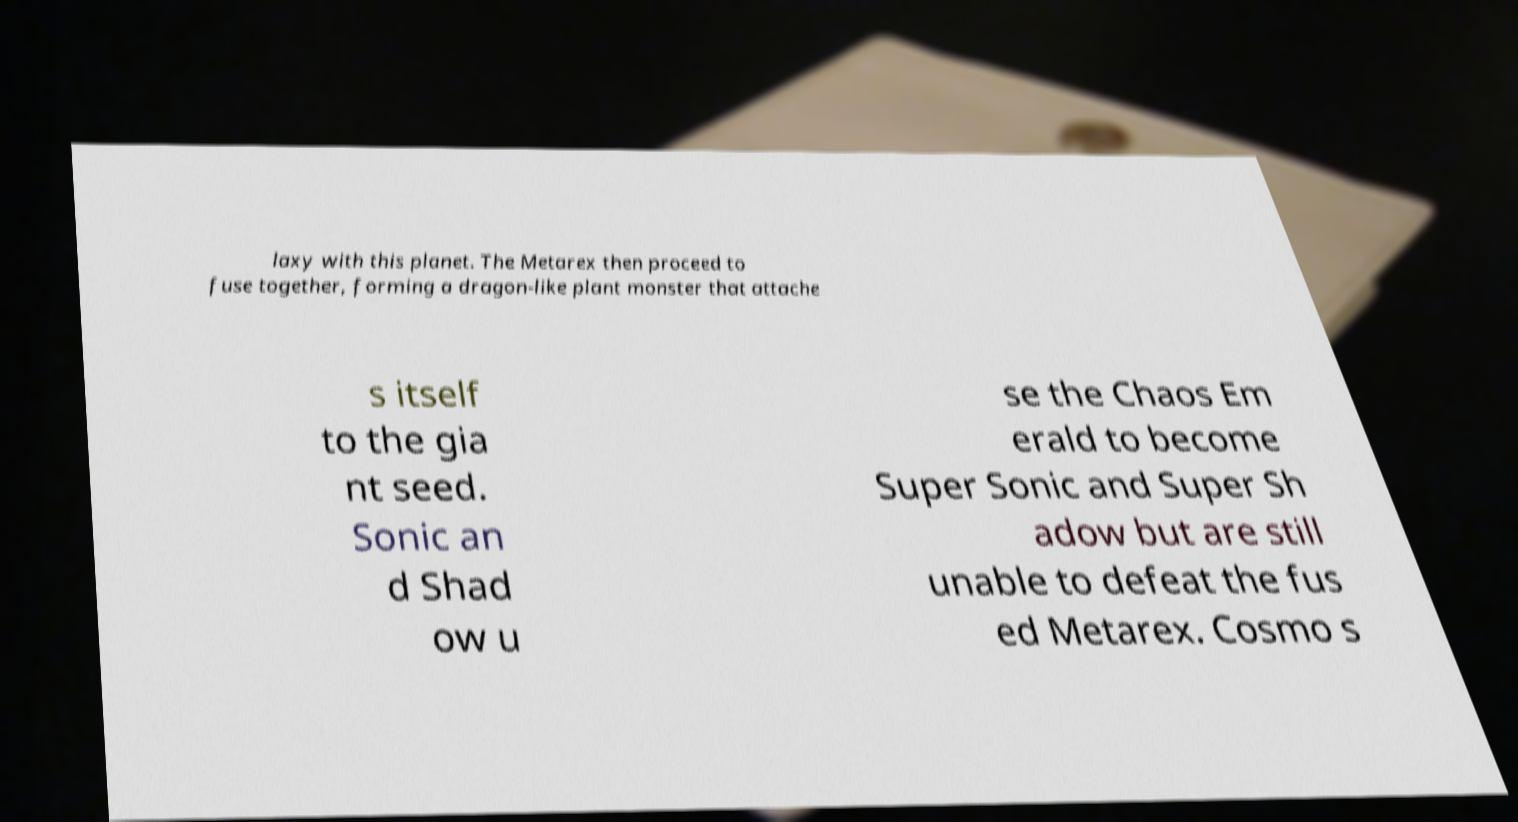What messages or text are displayed in this image? I need them in a readable, typed format. laxy with this planet. The Metarex then proceed to fuse together, forming a dragon-like plant monster that attache s itself to the gia nt seed. Sonic an d Shad ow u se the Chaos Em erald to become Super Sonic and Super Sh adow but are still unable to defeat the fus ed Metarex. Cosmo s 